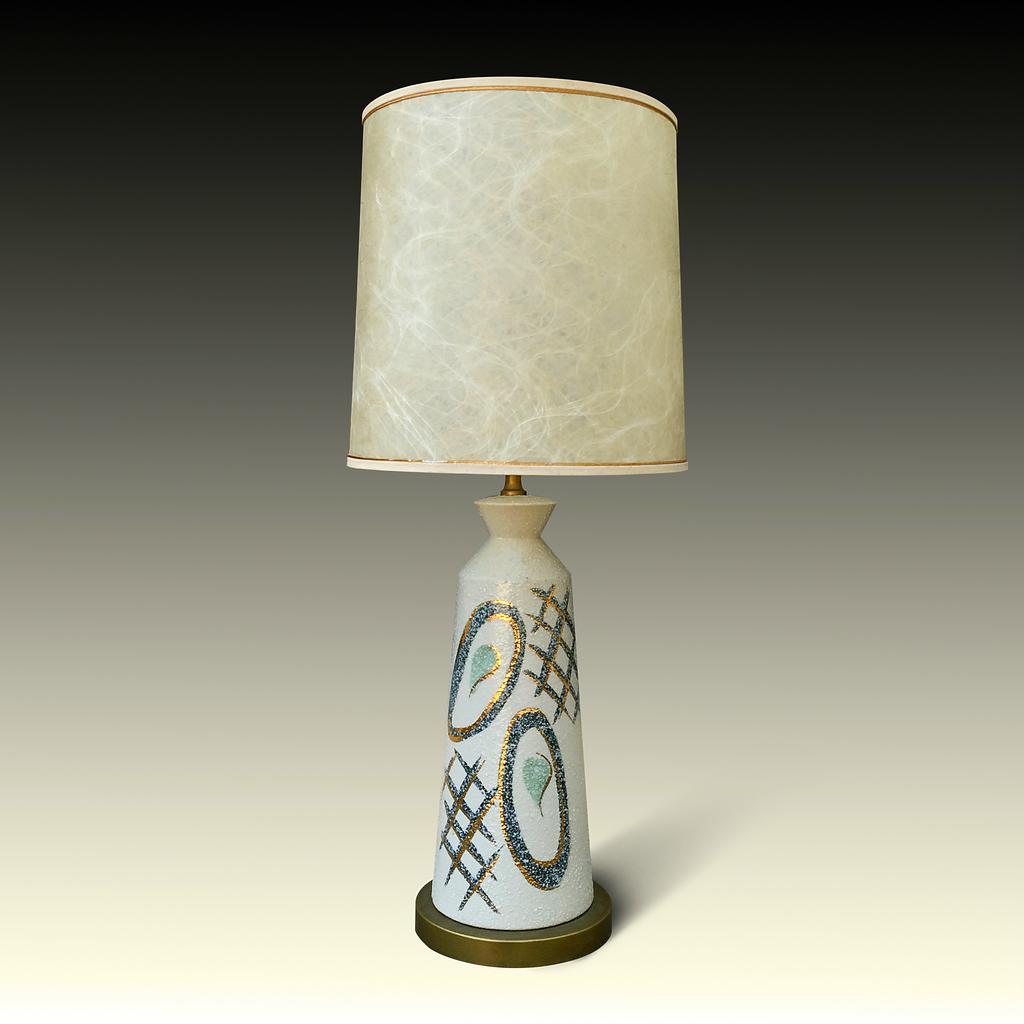Please provide a concise description of this image. In this picture I can see a lamp on an object. 